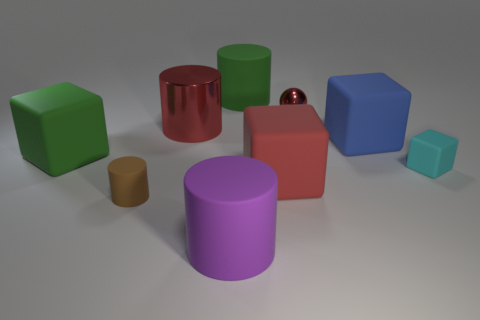Add 1 large things. How many objects exist? 10 Subtract all cylinders. How many objects are left? 5 Add 7 red balls. How many red balls exist? 8 Subtract 0 gray cylinders. How many objects are left? 9 Subtract all tiny gray matte cylinders. Subtract all brown objects. How many objects are left? 8 Add 8 tiny brown rubber objects. How many tiny brown rubber objects are left? 9 